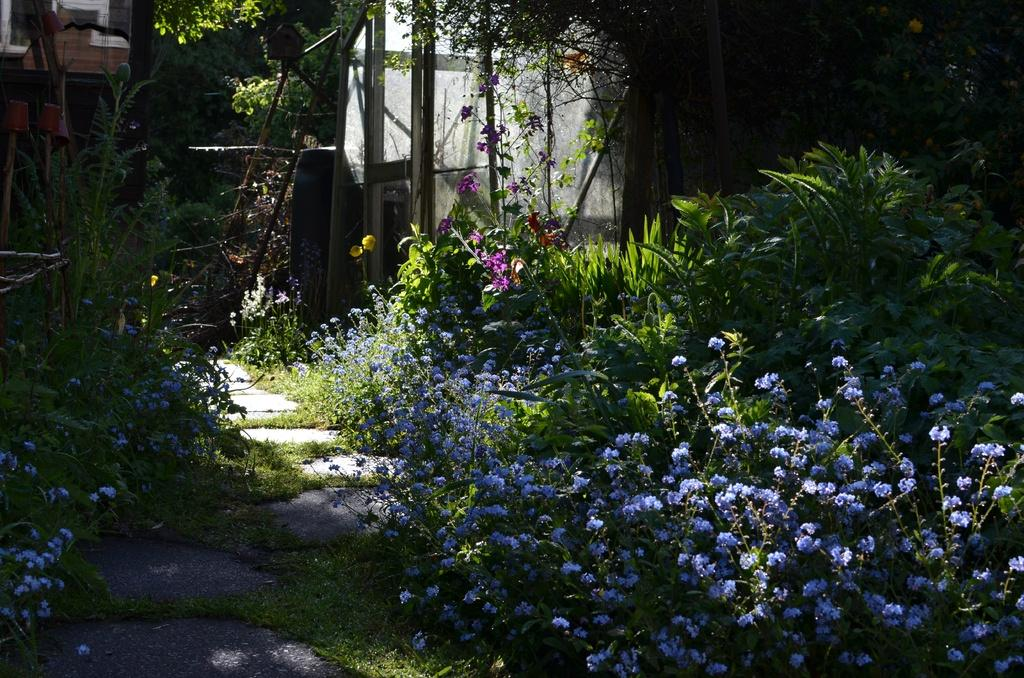What type of vegetation can be seen in the image? There are flowers, grass, plants, and trees in the image. What is the ground surface like in the image? The ground surface is covered with grass. What structures can be seen in the background of the image? There are poles in the background of the image. How many shoes are hanging from the trees in the image? There are no shoes hanging from the trees in the image. What type of addition problem can be solved using the number of flowers and trees in the image? There is no addition problem involving the number of flowers and trees in the image, as the facts provided do not specify the quantity of these elements. 